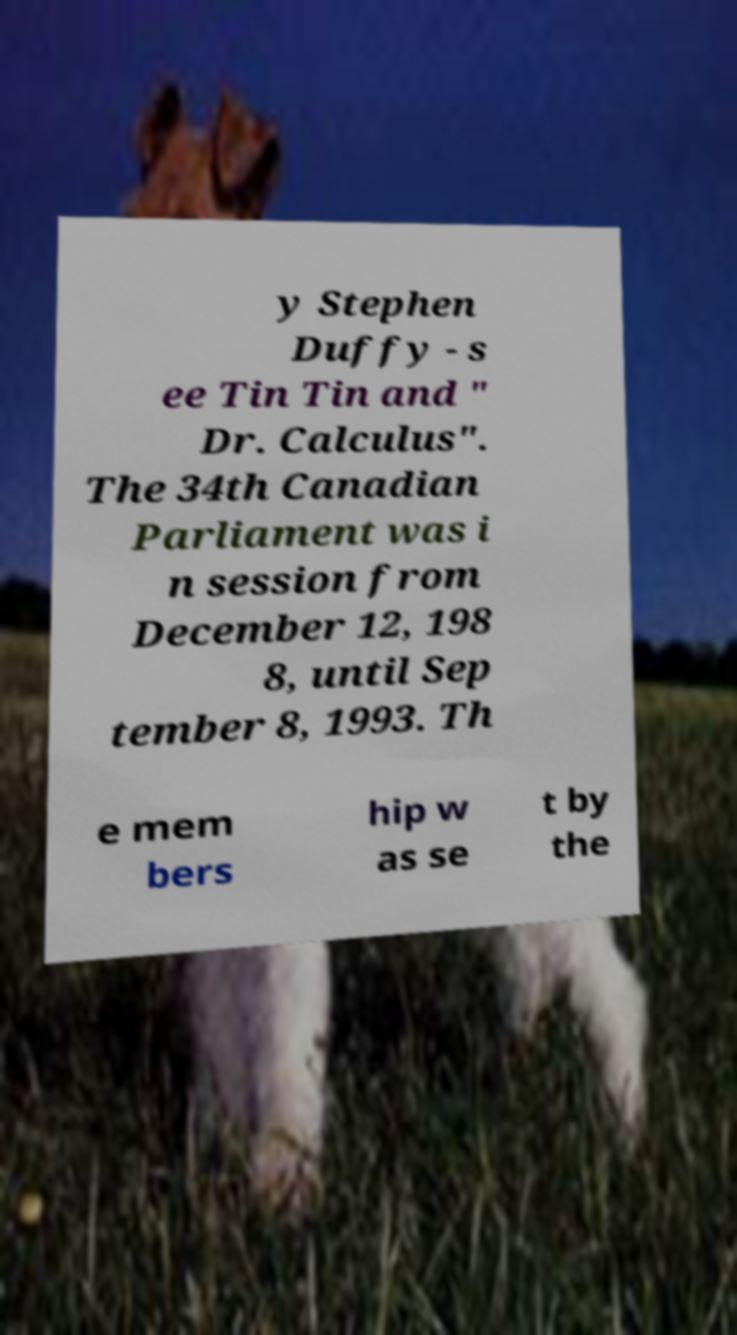I need the written content from this picture converted into text. Can you do that? y Stephen Duffy - s ee Tin Tin and " Dr. Calculus". The 34th Canadian Parliament was i n session from December 12, 198 8, until Sep tember 8, 1993. Th e mem bers hip w as se t by the 